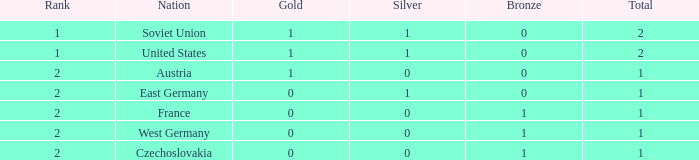What is the total number of bronze medals of West Germany, which is ranked 2 and has less than 1 total medals? 0.0. 